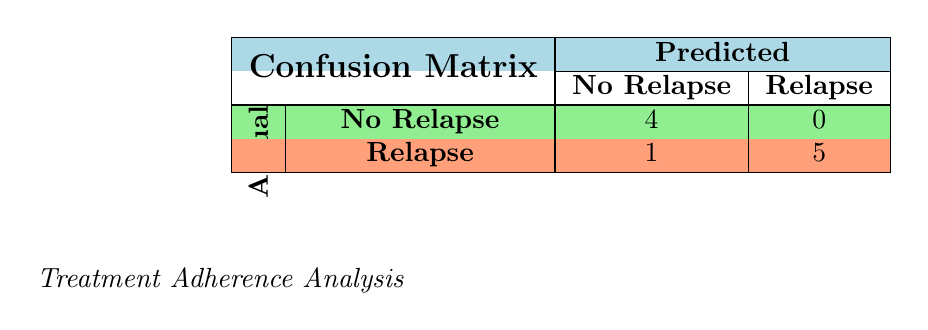What is the total number of patients who experienced relapse? The table shows that there are a total of 6 patients in the 'Relapse' category (1 from 'No Relapse' and 5 from 'Relapse'). Therefore, to find the total number of patients who experienced relapse, we add the counts from the 'Relapse' row, resulting in 1 + 5 = 6.
Answer: 6 How many patients had no relapse according to the table? The table's 'No Relapse' count indicates that there are 4 patients who did not experience relapse. This is found directly in the 'No Relapse' row under the 'Actual' column.
Answer: 4 What percentage of patients who relapsed had low treatment adherence? Among the 'Relapse' patients, there are 5 who relapsed, and out of these, only 1 had low adherence. To find the percentage, we perform the calculation (1/5) * 100%, resulting in 20%.
Answer: 20% What is the overall accuracy of the treatment program based on the confusion matrix? The accuracy can be calculated by dividing the sum of 'No Relapse' true positives and 'Relapse' true negatives by the total number of patients. From the table, the total is (4 + 5) out of (4 + 1 + 5 + 0) = 9. Thus, the accuracy is (9 / 10) * 100%, giving us 90%.
Answer: 90% Is it true that no patients who adhered high to treatment experienced a relapse? According to the table, looking at the 'No Relapse' count, all 4 patients with high treatment adherence did not experience a relapse. Therefore, the statement is true as it aligns with the data provided.
Answer: Yes What is the difference in relapse rates between patients with high adherence and those with low adherence? There are 4 patients with high adherence (all had no relapse) and 2 patients with low adherence (both had relapse). To find the difference in the number of relapses, we take 2 (low adherence relapses) - 0 (high adherence relapses) = 2. This indicates that patients with low adherence had 2 more relapses compared to those with high adherence.
Answer: 2 How many patients were correctly predicted to have no relapse? From the table, 4 patients were correctly predicted to have no relapse, as reflected in the count of 'No Relapse' under the actual values. Thus, the answer is found directly in the table without further calculations.
Answer: 4 What counts the total number of predicted relapses as accurate? The table displays that 5 patients were correctly predicted to have relapsed. This is evident from the 'Relapse' true positive figure in the matrix. Hence, the total number of accurate predictions for relapses is directly taken from the table.
Answer: 5 